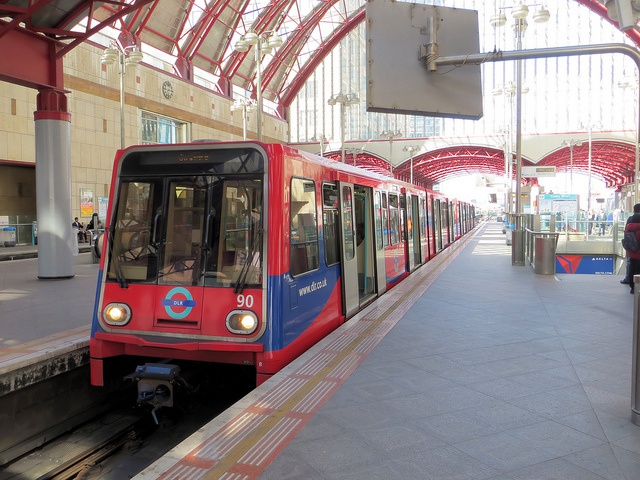Describe the objects in this image and their specific colors. I can see train in black, gray, brown, and maroon tones, people in black, maroon, and purple tones, backpack in black and gray tones, people in black, lightgray, darkgray, and lightblue tones, and people in black and gray tones in this image. 